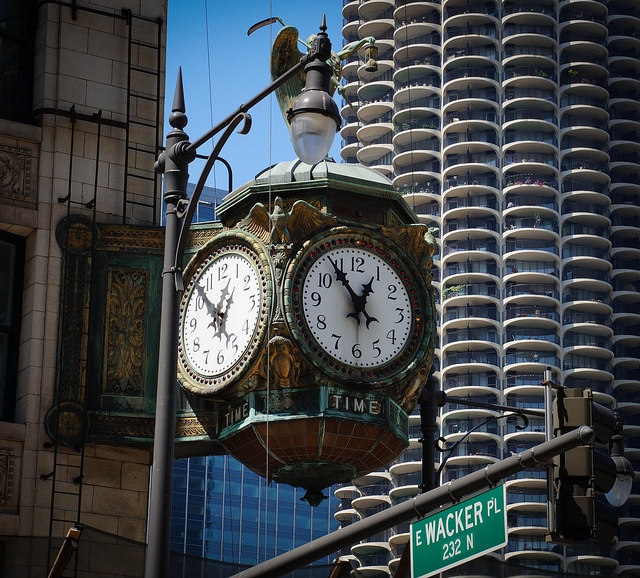<image>What animals are decorating the clock? It's ambiguous what animals are decorating the clock. It can be either birds, eagles or none. What animals are decorating the clock? I am not sure which animals are decorating the clock. It can be seen birds, eagle or eagles. 